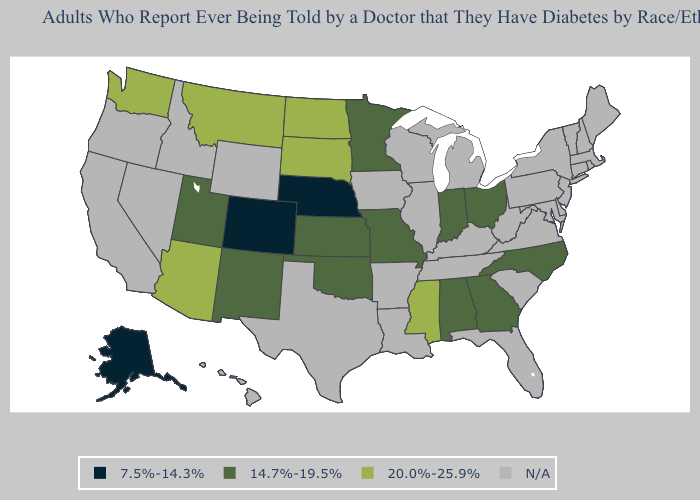Name the states that have a value in the range N/A?
Short answer required. Arkansas, California, Connecticut, Delaware, Florida, Hawaii, Idaho, Illinois, Iowa, Kentucky, Louisiana, Maine, Maryland, Massachusetts, Michigan, Nevada, New Hampshire, New Jersey, New York, Oregon, Pennsylvania, Rhode Island, South Carolina, Tennessee, Texas, Vermont, Virginia, West Virginia, Wisconsin, Wyoming. Name the states that have a value in the range 7.5%-14.3%?
Write a very short answer. Alaska, Colorado, Nebraska. Among the states that border Illinois , which have the highest value?
Concise answer only. Indiana, Missouri. Does Missouri have the lowest value in the USA?
Concise answer only. No. Does South Dakota have the highest value in the MidWest?
Give a very brief answer. Yes. Name the states that have a value in the range 14.7%-19.5%?
Concise answer only. Alabama, Georgia, Indiana, Kansas, Minnesota, Missouri, New Mexico, North Carolina, Ohio, Oklahoma, Utah. What is the value of Arizona?
Be succinct. 20.0%-25.9%. Which states hav the highest value in the South?
Keep it brief. Mississippi. What is the value of Arkansas?
Be succinct. N/A. Does North Carolina have the highest value in the South?
Keep it brief. No. What is the value of Wisconsin?
Write a very short answer. N/A. What is the value of Colorado?
Write a very short answer. 7.5%-14.3%. Name the states that have a value in the range 7.5%-14.3%?
Answer briefly. Alaska, Colorado, Nebraska. 